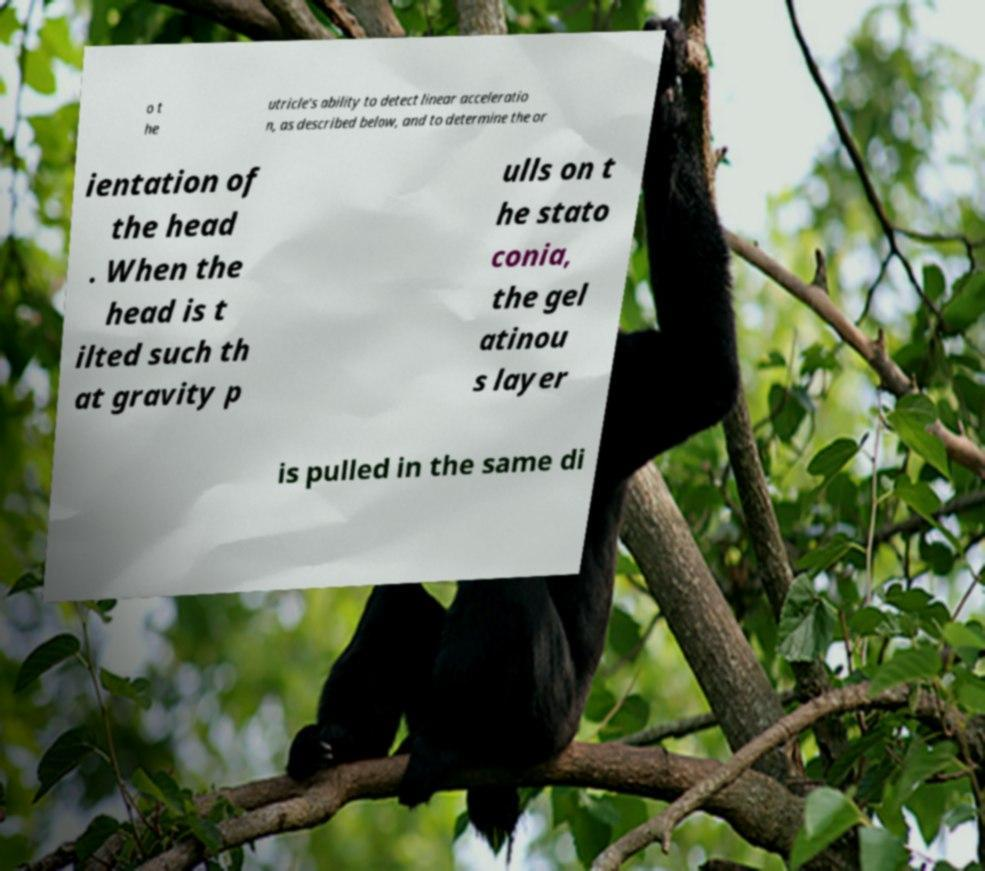Please read and relay the text visible in this image. What does it say? o t he utricle's ability to detect linear acceleratio n, as described below, and to determine the or ientation of the head . When the head is t ilted such th at gravity p ulls on t he stato conia, the gel atinou s layer is pulled in the same di 